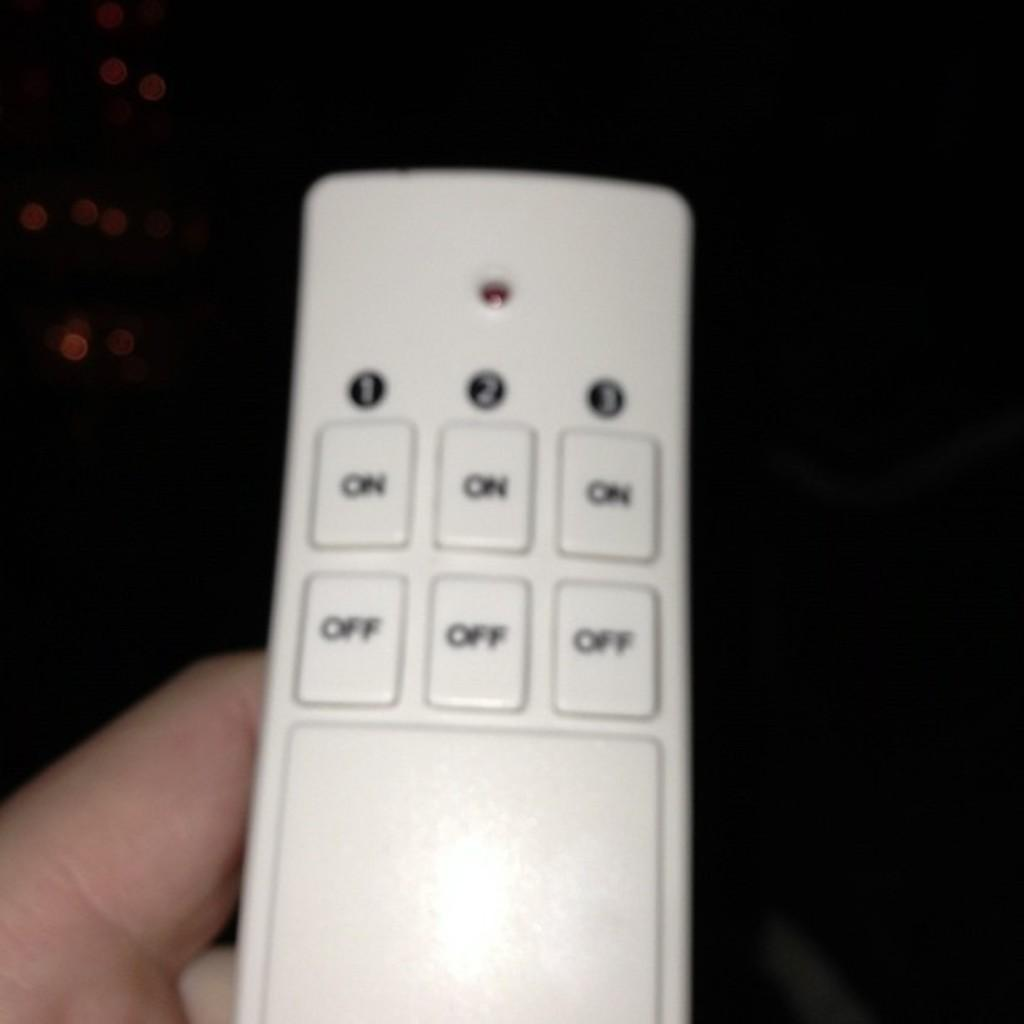<image>
Summarize the visual content of the image. A person holds a remote with three on and off buttons. 